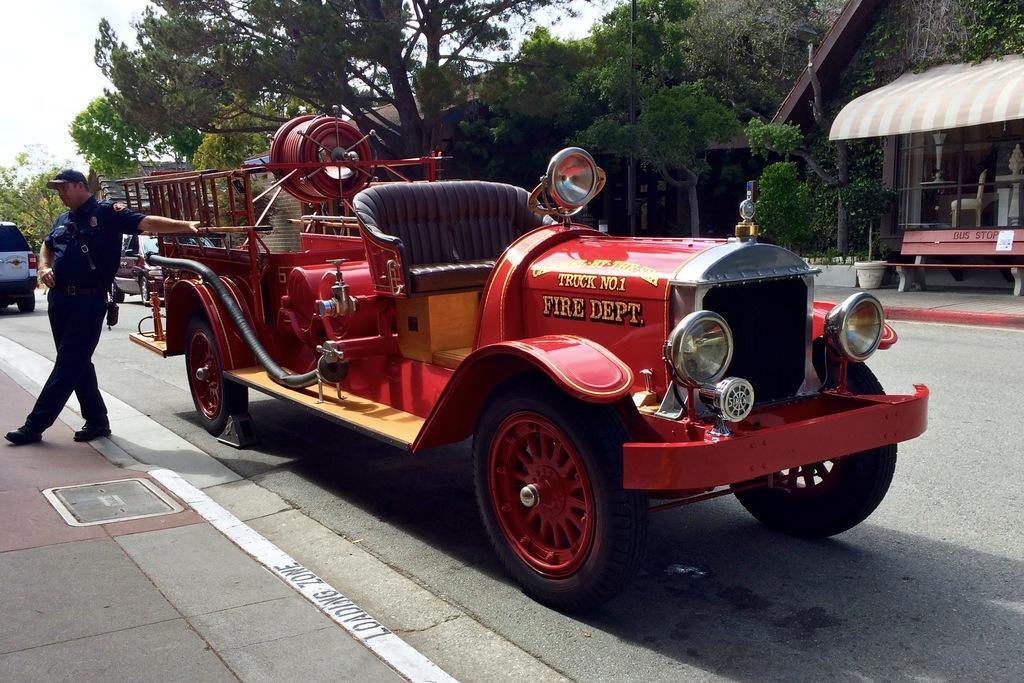Please provide a concise description of this image. In this image, I can see a person standing and there are vehicles on the road. On the right side of the image, there is a house with glass windows, flower pot with a plant and I can see a bench. In the background, I can see buildings, trees and there is the sky. 